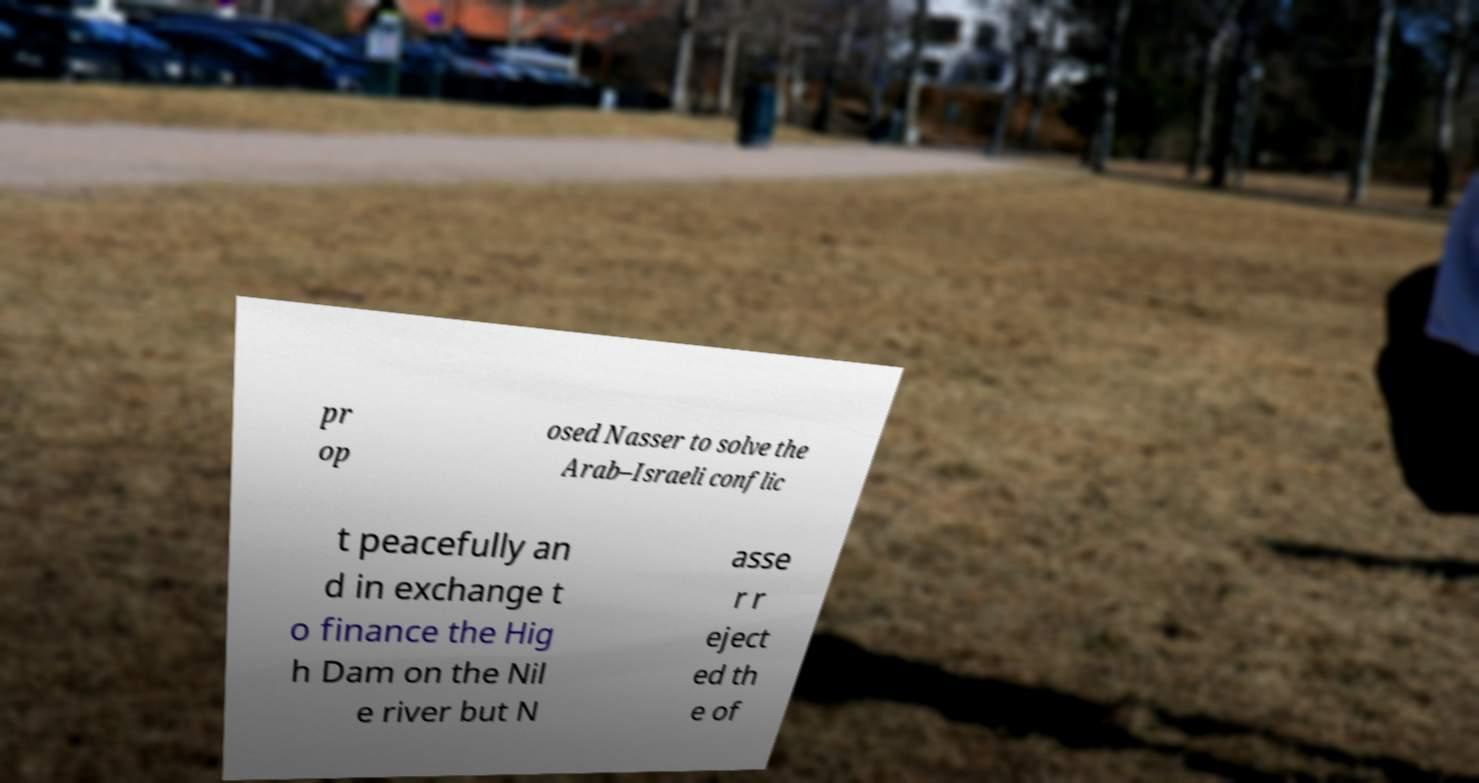For documentation purposes, I need the text within this image transcribed. Could you provide that? pr op osed Nasser to solve the Arab–Israeli conflic t peacefully an d in exchange t o finance the Hig h Dam on the Nil e river but N asse r r eject ed th e of 